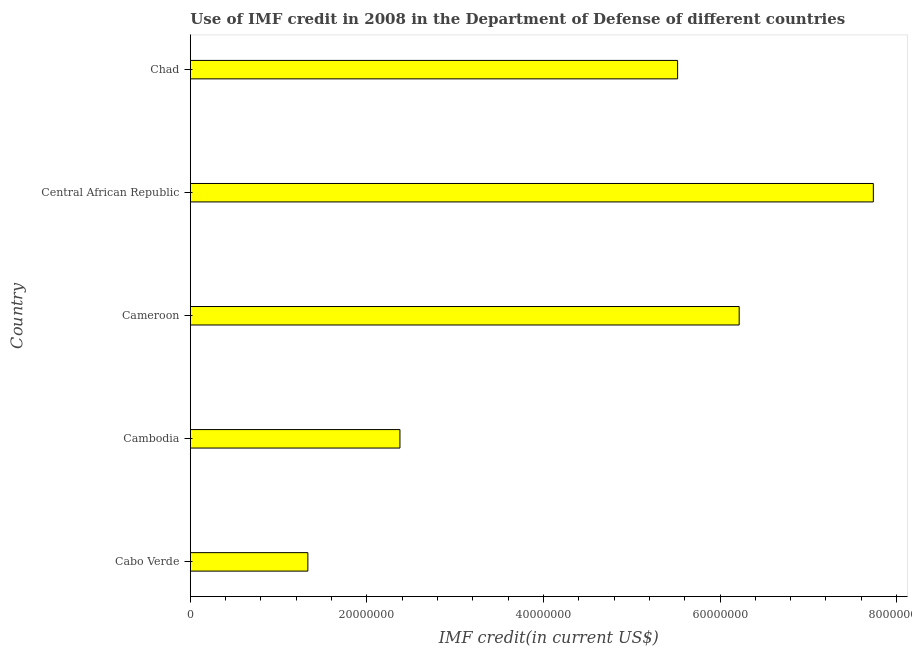What is the title of the graph?
Ensure brevity in your answer.  Use of IMF credit in 2008 in the Department of Defense of different countries. What is the label or title of the X-axis?
Offer a terse response. IMF credit(in current US$). What is the label or title of the Y-axis?
Give a very brief answer. Country. What is the use of imf credit in dod in Cabo Verde?
Your answer should be compact. 1.33e+07. Across all countries, what is the maximum use of imf credit in dod?
Offer a very short reply. 7.74e+07. Across all countries, what is the minimum use of imf credit in dod?
Make the answer very short. 1.33e+07. In which country was the use of imf credit in dod maximum?
Provide a succinct answer. Central African Republic. In which country was the use of imf credit in dod minimum?
Your response must be concise. Cabo Verde. What is the sum of the use of imf credit in dod?
Your response must be concise. 2.32e+08. What is the difference between the use of imf credit in dod in Cabo Verde and Cameroon?
Your answer should be very brief. -4.89e+07. What is the average use of imf credit in dod per country?
Offer a very short reply. 4.64e+07. What is the median use of imf credit in dod?
Provide a succinct answer. 5.52e+07. What is the ratio of the use of imf credit in dod in Cabo Verde to that in Cambodia?
Provide a short and direct response. 0.56. Is the use of imf credit in dod in Cabo Verde less than that in Chad?
Your response must be concise. Yes. Is the difference between the use of imf credit in dod in Cabo Verde and Cameroon greater than the difference between any two countries?
Provide a short and direct response. No. What is the difference between the highest and the second highest use of imf credit in dod?
Give a very brief answer. 1.52e+07. Is the sum of the use of imf credit in dod in Cabo Verde and Chad greater than the maximum use of imf credit in dod across all countries?
Your answer should be compact. No. What is the difference between the highest and the lowest use of imf credit in dod?
Keep it short and to the point. 6.40e+07. How many countries are there in the graph?
Your answer should be very brief. 5. Are the values on the major ticks of X-axis written in scientific E-notation?
Provide a succinct answer. No. What is the IMF credit(in current US$) in Cabo Verde?
Your answer should be very brief. 1.33e+07. What is the IMF credit(in current US$) in Cambodia?
Your answer should be compact. 2.37e+07. What is the IMF credit(in current US$) in Cameroon?
Offer a very short reply. 6.22e+07. What is the IMF credit(in current US$) of Central African Republic?
Your response must be concise. 7.74e+07. What is the IMF credit(in current US$) of Chad?
Your answer should be compact. 5.52e+07. What is the difference between the IMF credit(in current US$) in Cabo Verde and Cambodia?
Keep it short and to the point. -1.04e+07. What is the difference between the IMF credit(in current US$) in Cabo Verde and Cameroon?
Your answer should be very brief. -4.89e+07. What is the difference between the IMF credit(in current US$) in Cabo Verde and Central African Republic?
Your answer should be compact. -6.40e+07. What is the difference between the IMF credit(in current US$) in Cabo Verde and Chad?
Ensure brevity in your answer.  -4.19e+07. What is the difference between the IMF credit(in current US$) in Cambodia and Cameroon?
Provide a succinct answer. -3.84e+07. What is the difference between the IMF credit(in current US$) in Cambodia and Central African Republic?
Your answer should be very brief. -5.36e+07. What is the difference between the IMF credit(in current US$) in Cambodia and Chad?
Keep it short and to the point. -3.14e+07. What is the difference between the IMF credit(in current US$) in Cameroon and Central African Republic?
Your answer should be very brief. -1.52e+07. What is the difference between the IMF credit(in current US$) in Cameroon and Chad?
Keep it short and to the point. 6.97e+06. What is the difference between the IMF credit(in current US$) in Central African Republic and Chad?
Your response must be concise. 2.22e+07. What is the ratio of the IMF credit(in current US$) in Cabo Verde to that in Cambodia?
Give a very brief answer. 0.56. What is the ratio of the IMF credit(in current US$) in Cabo Verde to that in Cameroon?
Your response must be concise. 0.21. What is the ratio of the IMF credit(in current US$) in Cabo Verde to that in Central African Republic?
Offer a terse response. 0.17. What is the ratio of the IMF credit(in current US$) in Cabo Verde to that in Chad?
Your response must be concise. 0.24. What is the ratio of the IMF credit(in current US$) in Cambodia to that in Cameroon?
Your answer should be very brief. 0.38. What is the ratio of the IMF credit(in current US$) in Cambodia to that in Central African Republic?
Provide a short and direct response. 0.31. What is the ratio of the IMF credit(in current US$) in Cambodia to that in Chad?
Offer a terse response. 0.43. What is the ratio of the IMF credit(in current US$) in Cameroon to that in Central African Republic?
Offer a terse response. 0.8. What is the ratio of the IMF credit(in current US$) in Cameroon to that in Chad?
Offer a very short reply. 1.13. What is the ratio of the IMF credit(in current US$) in Central African Republic to that in Chad?
Keep it short and to the point. 1.4. 